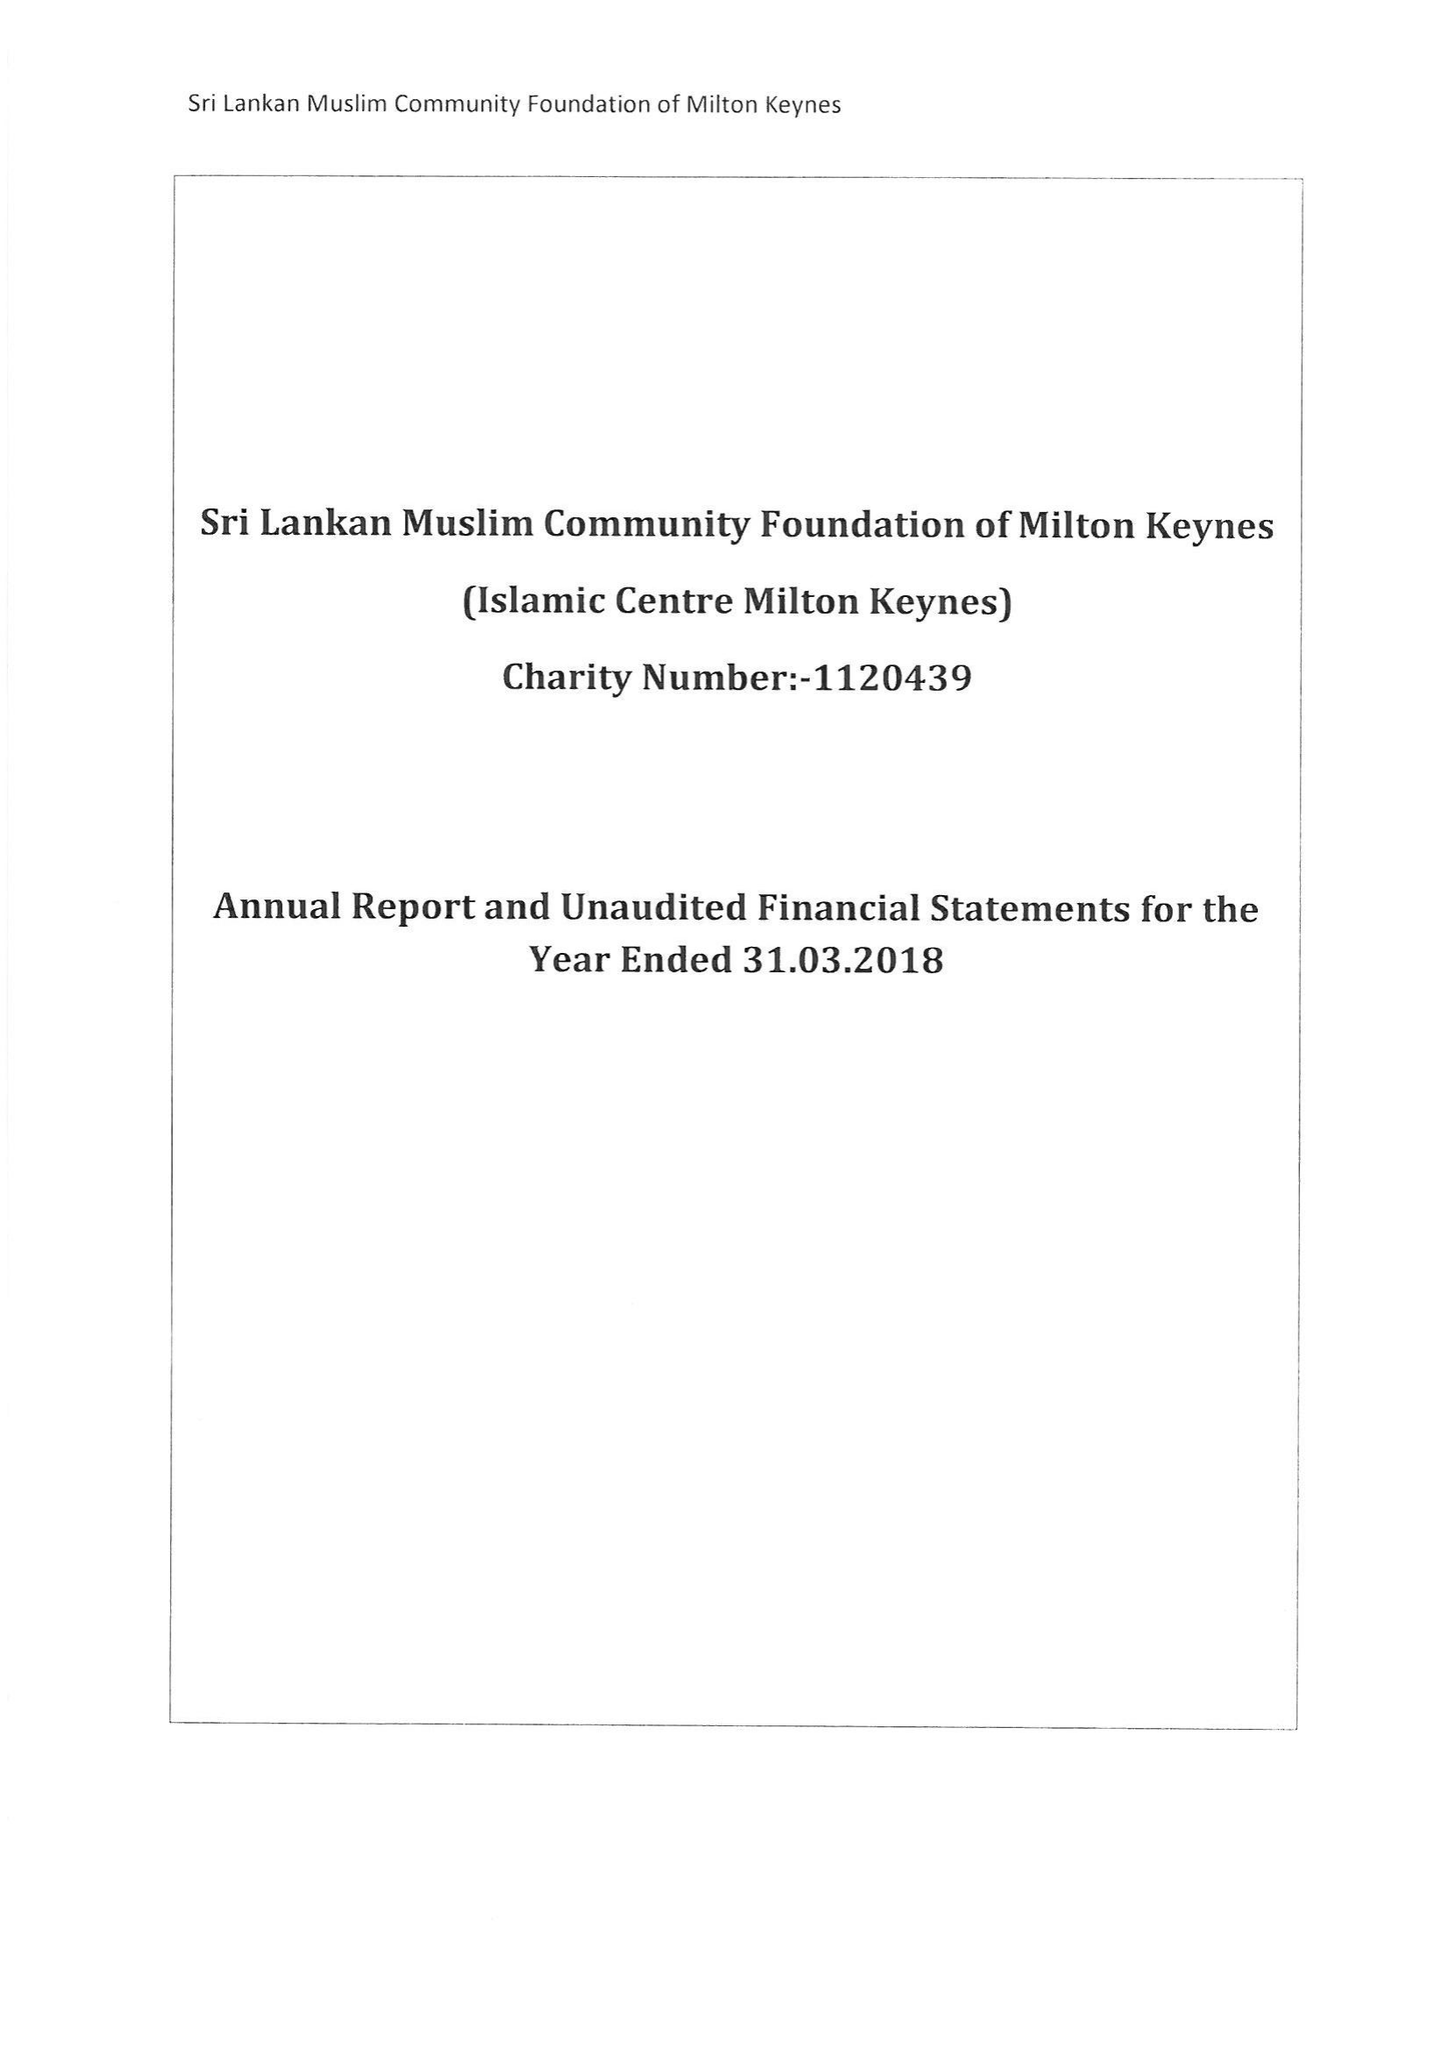What is the value for the address__post_town?
Answer the question using a single word or phrase. MILTON KEYNES 